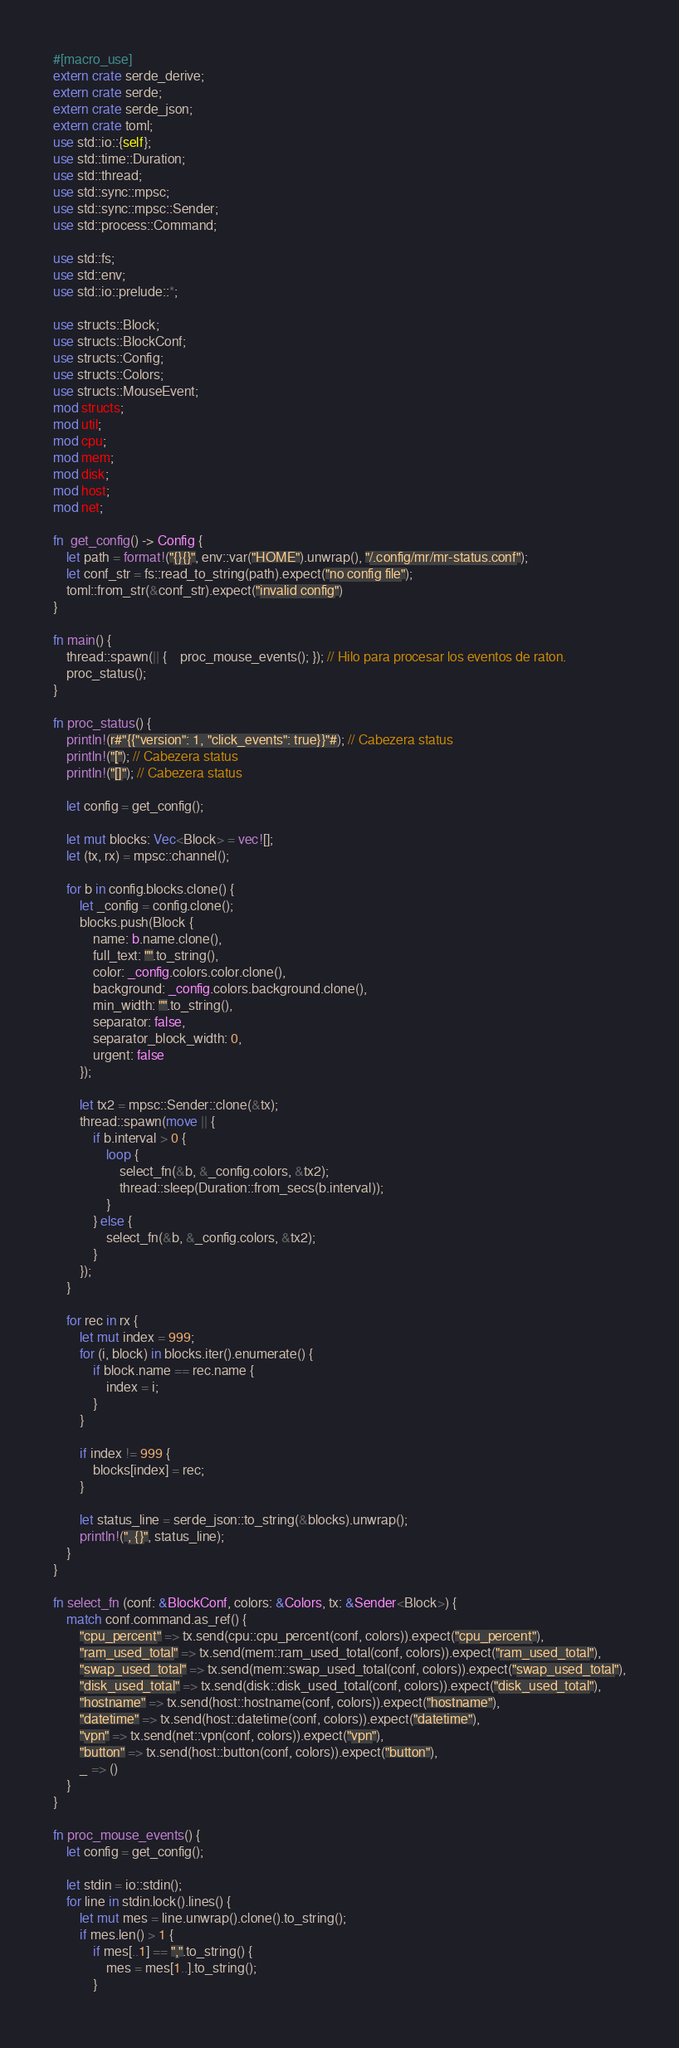Convert code to text. <code><loc_0><loc_0><loc_500><loc_500><_Rust_>
#[macro_use]
extern crate serde_derive;
extern crate serde;
extern crate serde_json;
extern crate toml;
use std::io::{self};
use std::time::Duration;
use std::thread;
use std::sync::mpsc;
use std::sync::mpsc::Sender;
use std::process::Command;

use std::fs;
use std::env;
use std::io::prelude::*;

use structs::Block;
use structs::BlockConf;
use structs::Config;
use structs::Colors;
use structs::MouseEvent;
mod structs;
mod util;
mod cpu;
mod mem;
mod disk;
mod host;
mod net;

fn  get_config() -> Config {
	let path = format!("{}{}", env::var("HOME").unwrap(), "/.config/mr/mr-status.conf");
	let conf_str = fs::read_to_string(path).expect("no config file");
	toml::from_str(&conf_str).expect("invalid config")
}

fn main() {
    thread::spawn(|| { 	proc_mouse_events(); }); // Hilo para procesar los eventos de raton.
	proc_status(); 
}

fn proc_status() {
	println!(r#"{{"version": 1, "click_events": true}}"#); // Cabezera status
	println!("["); // Cabezera status
	println!("[]"); // Cabezera status

	let config = get_config();
	
	let mut blocks: Vec<Block> = vec![]; 
	let (tx, rx) = mpsc::channel();
	
	for b in config.blocks.clone() {
		let _config = config.clone();
		blocks.push(Block {
			name: b.name.clone(),
			full_text: "".to_string(),
			color: _config.colors.color.clone(),
			background: _config.colors.background.clone(),
			min_width: "".to_string(),
			separator: false,
			separator_block_width: 0,
			urgent: false
		});
		
		let tx2 = mpsc::Sender::clone(&tx);
		thread::spawn(move || {
			if b.interval > 0 {
				loop {
					select_fn(&b, &_config.colors, &tx2);
					thread::sleep(Duration::from_secs(b.interval));
				}
			} else {
				select_fn(&b, &_config.colors, &tx2);
			}
		});
	}
	
    for rec in rx {
		let mut index = 999;
		for (i, block) in blocks.iter().enumerate() {
			if block.name == rec.name {
				index = i;
			}
		}
		
		if index != 999 {
			blocks[index] = rec;
		}
		
		let status_line = serde_json::to_string(&blocks).unwrap();
		println!(", {}", status_line);
    }    
}

fn select_fn (conf: &BlockConf, colors: &Colors, tx: &Sender<Block>) {
	match conf.command.as_ref() {
		"cpu_percent" => tx.send(cpu::cpu_percent(conf, colors)).expect("cpu_percent"),
		"ram_used_total" => tx.send(mem::ram_used_total(conf, colors)).expect("ram_used_total"),
		"swap_used_total" => tx.send(mem::swap_used_total(conf, colors)).expect("swap_used_total"),
		"disk_used_total" => tx.send(disk::disk_used_total(conf, colors)).expect("disk_used_total"),
		"hostname" => tx.send(host::hostname(conf, colors)).expect("hostname"),
		"datetime" => tx.send(host::datetime(conf, colors)).expect("datetime"),
		"vpn" => tx.send(net::vpn(conf, colors)).expect("vpn"),
		"button" => tx.send(host::button(conf, colors)).expect("button"),
		_ => ()		
	}
}

fn proc_mouse_events() {
	let config = get_config();
	
    let stdin = io::stdin();
	for line in stdin.lock().lines() {
		let mut mes = line.unwrap().clone().to_string();
		if mes.len() > 1 {
			if mes[..1] == ",".to_string() {
				mes = mes[1..].to_string();
			}</code> 